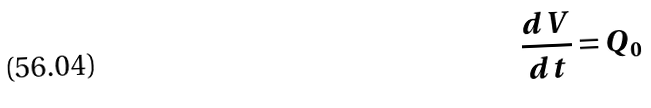Convert formula to latex. <formula><loc_0><loc_0><loc_500><loc_500>\frac { d V } { d t } = Q _ { 0 }</formula> 